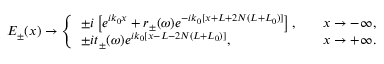<formula> <loc_0><loc_0><loc_500><loc_500>E _ { \pm } ( x ) \rightarrow \left \{ \begin{array} { l l } { \pm i \left [ e ^ { i k _ { 0 } x } + r _ { \pm } ( \omega ) e ^ { - i k _ { 0 } [ x + L + 2 N ( L + L _ { 0 } ) ] } \right ] , } & { \quad x \rightarrow - \infty , } \\ { \pm i t _ { \pm } ( \omega ) e ^ { i k _ { 0 } [ x - L - 2 N ( L + L _ { 0 } ) ] } , } & { \quad x \rightarrow + \infty . } \end{array}</formula> 